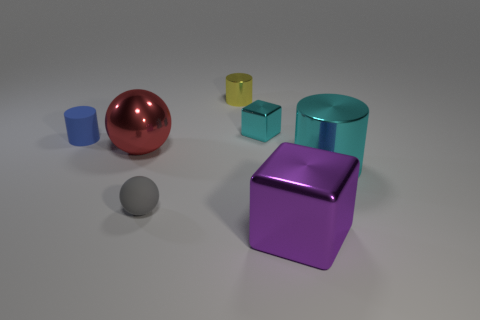There is a cylinder that is the same size as the red ball; what is its color?
Offer a very short reply. Cyan. How many large objects are either yellow matte cubes or yellow shiny cylinders?
Make the answer very short. 0. The large thing that is behind the gray sphere and on the right side of the small gray matte sphere is made of what material?
Make the answer very short. Metal. Is the shape of the small rubber object that is right of the red metallic ball the same as the big metallic object that is behind the big cyan metal cylinder?
Ensure brevity in your answer.  Yes. There is a metallic object that is the same color as the small block; what is its shape?
Your response must be concise. Cylinder. What number of things are either cyan metal cubes to the right of the blue rubber cylinder or balls?
Your answer should be very brief. 3. Do the gray rubber sphere and the blue thing have the same size?
Provide a succinct answer. Yes. The tiny rubber thing that is behind the big metallic cylinder is what color?
Your answer should be very brief. Blue. What is the size of the cyan cylinder that is the same material as the purple cube?
Keep it short and to the point. Large. Do the blue cylinder and the metallic cylinder in front of the big metallic sphere have the same size?
Your answer should be very brief. No. 